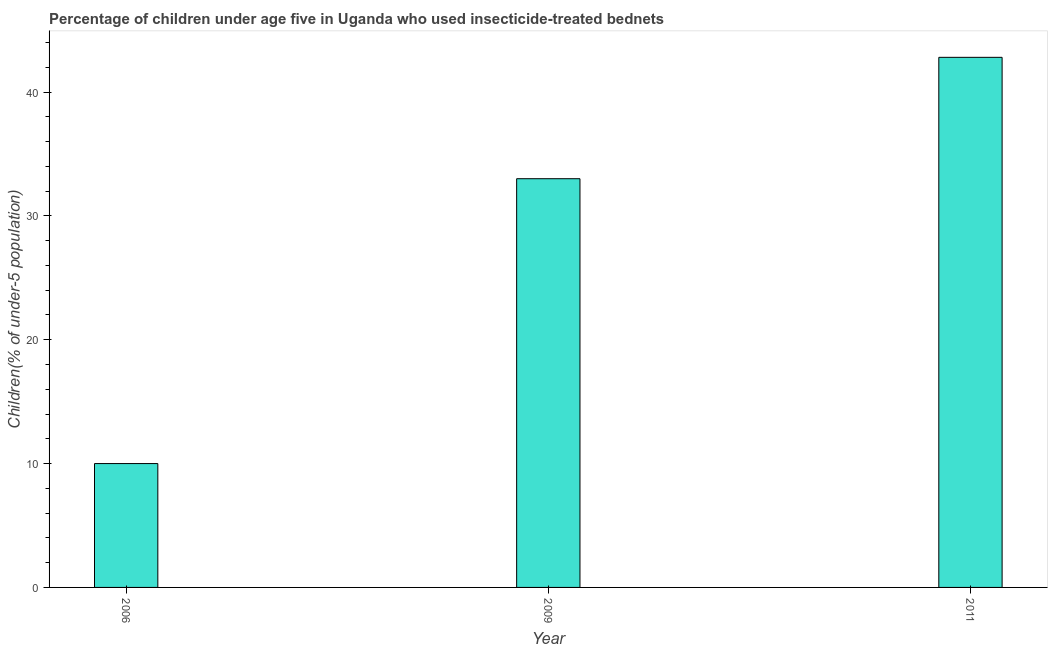Does the graph contain any zero values?
Make the answer very short. No. Does the graph contain grids?
Make the answer very short. No. What is the title of the graph?
Provide a short and direct response. Percentage of children under age five in Uganda who used insecticide-treated bednets. What is the label or title of the X-axis?
Provide a short and direct response. Year. What is the label or title of the Y-axis?
Provide a succinct answer. Children(% of under-5 population). What is the percentage of children who use of insecticide-treated bed nets in 2009?
Provide a short and direct response. 33. Across all years, what is the maximum percentage of children who use of insecticide-treated bed nets?
Your response must be concise. 42.8. In which year was the percentage of children who use of insecticide-treated bed nets maximum?
Your answer should be very brief. 2011. What is the sum of the percentage of children who use of insecticide-treated bed nets?
Make the answer very short. 85.8. What is the difference between the percentage of children who use of insecticide-treated bed nets in 2009 and 2011?
Make the answer very short. -9.8. What is the average percentage of children who use of insecticide-treated bed nets per year?
Ensure brevity in your answer.  28.6. In how many years, is the percentage of children who use of insecticide-treated bed nets greater than 34 %?
Give a very brief answer. 1. Do a majority of the years between 2006 and 2011 (inclusive) have percentage of children who use of insecticide-treated bed nets greater than 24 %?
Provide a short and direct response. Yes. What is the ratio of the percentage of children who use of insecticide-treated bed nets in 2006 to that in 2009?
Ensure brevity in your answer.  0.3. Is the difference between the percentage of children who use of insecticide-treated bed nets in 2006 and 2011 greater than the difference between any two years?
Your response must be concise. Yes. What is the difference between the highest and the lowest percentage of children who use of insecticide-treated bed nets?
Ensure brevity in your answer.  32.8. In how many years, is the percentage of children who use of insecticide-treated bed nets greater than the average percentage of children who use of insecticide-treated bed nets taken over all years?
Give a very brief answer. 2. Are all the bars in the graph horizontal?
Offer a terse response. No. Are the values on the major ticks of Y-axis written in scientific E-notation?
Your answer should be very brief. No. What is the Children(% of under-5 population) in 2009?
Keep it short and to the point. 33. What is the Children(% of under-5 population) of 2011?
Keep it short and to the point. 42.8. What is the difference between the Children(% of under-5 population) in 2006 and 2011?
Offer a terse response. -32.8. What is the ratio of the Children(% of under-5 population) in 2006 to that in 2009?
Offer a very short reply. 0.3. What is the ratio of the Children(% of under-5 population) in 2006 to that in 2011?
Keep it short and to the point. 0.23. What is the ratio of the Children(% of under-5 population) in 2009 to that in 2011?
Provide a succinct answer. 0.77. 